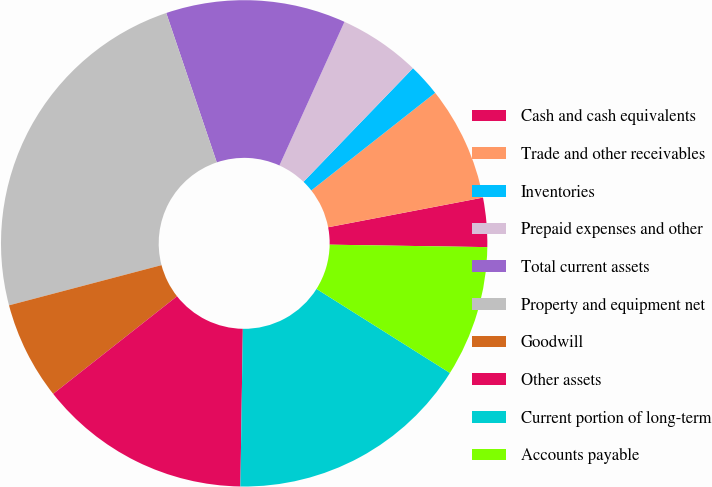Convert chart. <chart><loc_0><loc_0><loc_500><loc_500><pie_chart><fcel>Cash and cash equivalents<fcel>Trade and other receivables<fcel>Inventories<fcel>Prepaid expenses and other<fcel>Total current assets<fcel>Property and equipment net<fcel>Goodwill<fcel>Other assets<fcel>Current portion of long-term<fcel>Accounts payable<nl><fcel>3.26%<fcel>7.61%<fcel>2.17%<fcel>5.44%<fcel>11.96%<fcel>23.91%<fcel>6.52%<fcel>14.13%<fcel>16.3%<fcel>8.7%<nl></chart> 